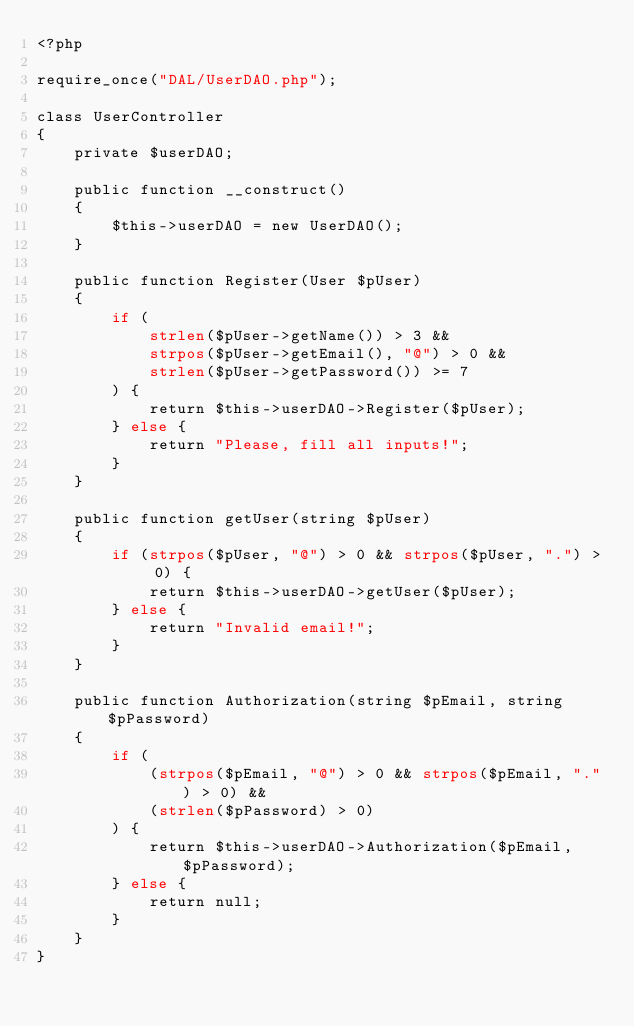<code> <loc_0><loc_0><loc_500><loc_500><_PHP_><?php

require_once("DAL/UserDAO.php");

class UserController
{
    private $userDAO;

    public function __construct()
    {
        $this->userDAO = new UserDAO();
    }

    public function Register(User $pUser)
    {
        if (
            strlen($pUser->getName()) > 3 &&
            strpos($pUser->getEmail(), "@") > 0 &&
            strlen($pUser->getPassword()) >= 7
        ) {
            return $this->userDAO->Register($pUser);
        } else {
            return "Please, fill all inputs!";
        }
    }

    public function getUser(string $pUser)
    {
        if (strpos($pUser, "@") > 0 && strpos($pUser, ".") > 0) {
            return $this->userDAO->getUser($pUser);
        } else {
            return "Invalid email!";
        }
    }

    public function Authorization(string $pEmail, string $pPassword)
    {
        if (
            (strpos($pEmail, "@") > 0 && strpos($pEmail, ".") > 0) &&
            (strlen($pPassword) > 0)
        ) {
            return $this->userDAO->Authorization($pEmail, $pPassword);
        } else {
            return null;
        }
    }
}
</code> 